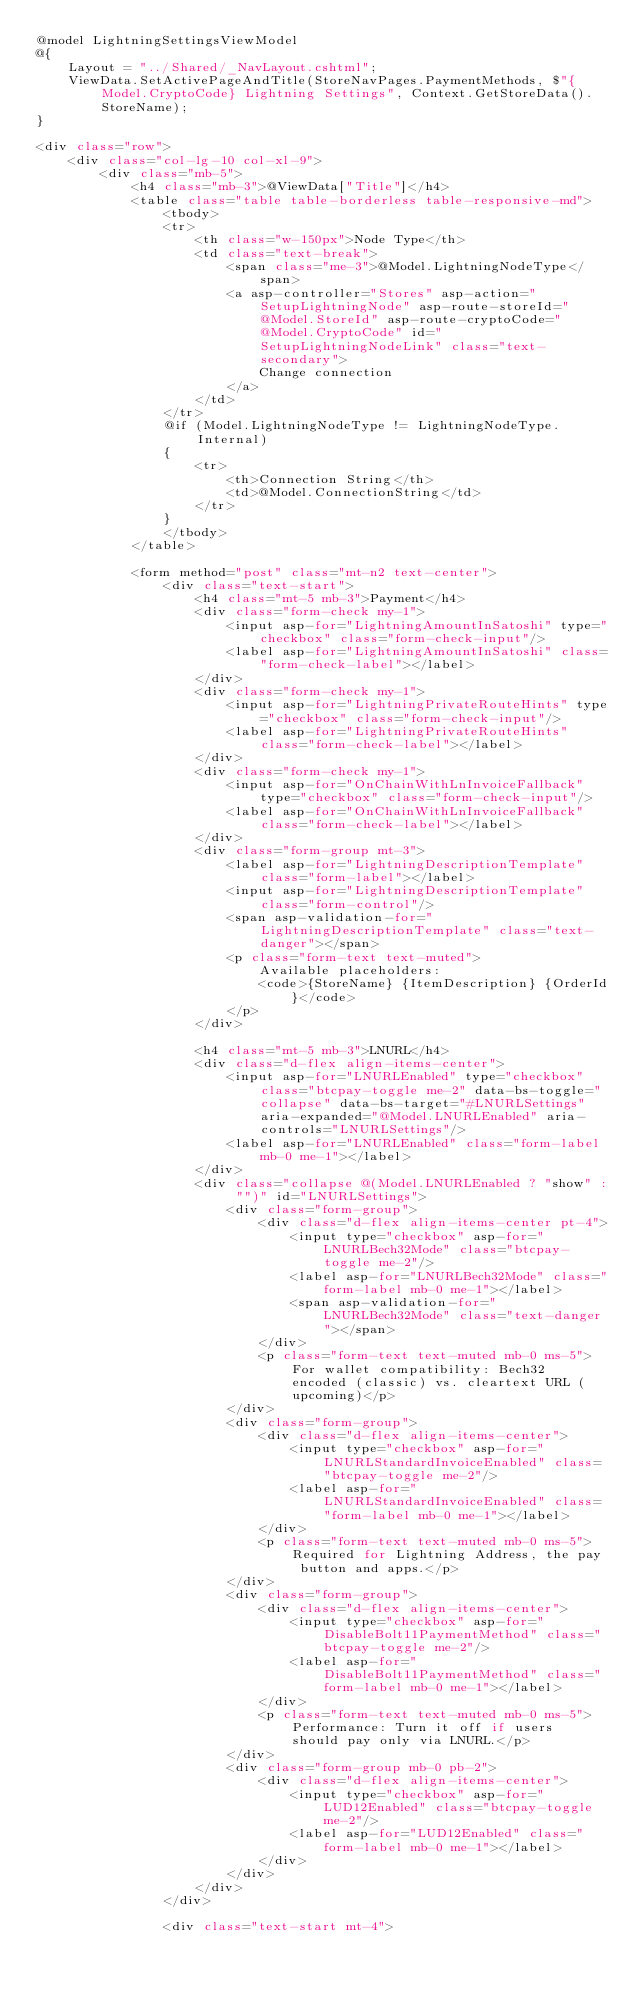<code> <loc_0><loc_0><loc_500><loc_500><_C#_>@model LightningSettingsViewModel
@{
    Layout = "../Shared/_NavLayout.cshtml";
    ViewData.SetActivePageAndTitle(StoreNavPages.PaymentMethods, $"{Model.CryptoCode} Lightning Settings", Context.GetStoreData().StoreName);
}

<div class="row">
    <div class="col-lg-10 col-xl-9">
        <div class="mb-5">
            <h4 class="mb-3">@ViewData["Title"]</h4>
            <table class="table table-borderless table-responsive-md">
                <tbody>
                <tr>
                    <th class="w-150px">Node Type</th>
                    <td class="text-break">
                        <span class="me-3">@Model.LightningNodeType</span>
                        <a asp-controller="Stores" asp-action="SetupLightningNode" asp-route-storeId="@Model.StoreId" asp-route-cryptoCode="@Model.CryptoCode" id="SetupLightningNodeLink" class="text-secondary">
                            Change connection
                        </a>
                    </td>
                </tr>
                @if (Model.LightningNodeType != LightningNodeType.Internal)
                {
                    <tr>
                        <th>Connection String</th>
                        <td>@Model.ConnectionString</td>
                    </tr>
                }
                </tbody>
            </table>
            
            <form method="post" class="mt-n2 text-center">
                <div class="text-start">
                    <h4 class="mt-5 mb-3">Payment</h4>
                    <div class="form-check my-1">
                        <input asp-for="LightningAmountInSatoshi" type="checkbox" class="form-check-input"/>
                        <label asp-for="LightningAmountInSatoshi" class="form-check-label"></label>
                    </div>
                    <div class="form-check my-1">
                        <input asp-for="LightningPrivateRouteHints" type="checkbox" class="form-check-input"/>
                        <label asp-for="LightningPrivateRouteHints" class="form-check-label"></label>
                    </div>
                    <div class="form-check my-1">
                        <input asp-for="OnChainWithLnInvoiceFallback" type="checkbox" class="form-check-input"/>
                        <label asp-for="OnChainWithLnInvoiceFallback" class="form-check-label"></label>
                    </div>
                    <div class="form-group mt-3">
                        <label asp-for="LightningDescriptionTemplate" class="form-label"></label>
                        <input asp-for="LightningDescriptionTemplate" class="form-control"/>
                        <span asp-validation-for="LightningDescriptionTemplate" class="text-danger"></span>
                        <p class="form-text text-muted">
                            Available placeholders:
                            <code>{StoreName} {ItemDescription} {OrderId}</code>
                        </p>
                    </div>
                    
                    <h4 class="mt-5 mb-3">LNURL</h4>
                    <div class="d-flex align-items-center">
                        <input asp-for="LNURLEnabled" type="checkbox" class="btcpay-toggle me-2" data-bs-toggle="collapse" data-bs-target="#LNURLSettings" aria-expanded="@Model.LNURLEnabled" aria-controls="LNURLSettings"/>
                        <label asp-for="LNURLEnabled" class="form-label mb-0 me-1"></label>
                    </div>
                    <div class="collapse @(Model.LNURLEnabled ? "show" : "")" id="LNURLSettings">
                        <div class="form-group">
                            <div class="d-flex align-items-center pt-4">
                                <input type="checkbox" asp-for="LNURLBech32Mode" class="btcpay-toggle me-2"/>
                                <label asp-for="LNURLBech32Mode" class="form-label mb-0 me-1"></label>
                                <span asp-validation-for="LNURLBech32Mode" class="text-danger"></span>
                            </div>
                            <p class="form-text text-muted mb-0 ms-5">For wallet compatibility: Bech32 encoded (classic) vs. cleartext URL (upcoming)</p>
                        </div>
                        <div class="form-group">
                            <div class="d-flex align-items-center">
                                <input type="checkbox" asp-for="LNURLStandardInvoiceEnabled" class="btcpay-toggle me-2"/>
                                <label asp-for="LNURLStandardInvoiceEnabled" class="form-label mb-0 me-1"></label>
                            </div>
                            <p class="form-text text-muted mb-0 ms-5">Required for Lightning Address, the pay button and apps.</p>
                        </div>
                        <div class="form-group">
                            <div class="d-flex align-items-center">
                                <input type="checkbox" asp-for="DisableBolt11PaymentMethod" class="btcpay-toggle me-2"/>
                                <label asp-for="DisableBolt11PaymentMethod" class="form-label mb-0 me-1"></label>
                            </div>
                            <p class="form-text text-muted mb-0 ms-5">Performance: Turn it off if users should pay only via LNURL.</p>
                        </div>
                        <div class="form-group mb-0 pb-2">
                            <div class="d-flex align-items-center">
                                <input type="checkbox" asp-for="LUD12Enabled" class="btcpay-toggle me-2"/>
                                <label asp-for="LUD12Enabled" class="form-label mb-0 me-1"></label>
                            </div>
                        </div>
                    </div>
                </div>

                <div class="text-start mt-4"></code> 